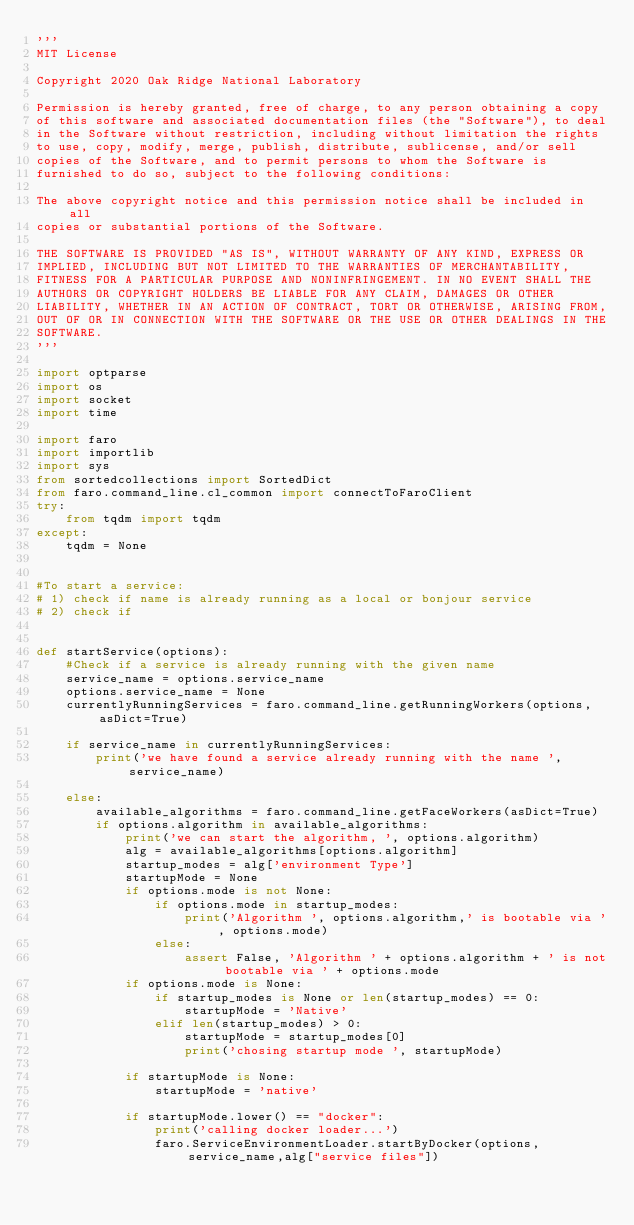<code> <loc_0><loc_0><loc_500><loc_500><_Python_>'''
MIT License

Copyright 2020 Oak Ridge National Laboratory

Permission is hereby granted, free of charge, to any person obtaining a copy
of this software and associated documentation files (the "Software"), to deal
in the Software without restriction, including without limitation the rights
to use, copy, modify, merge, publish, distribute, sublicense, and/or sell
copies of the Software, and to permit persons to whom the Software is
furnished to do so, subject to the following conditions:

The above copyright notice and this permission notice shall be included in all
copies or substantial portions of the Software.

THE SOFTWARE IS PROVIDED "AS IS", WITHOUT WARRANTY OF ANY KIND, EXPRESS OR
IMPLIED, INCLUDING BUT NOT LIMITED TO THE WARRANTIES OF MERCHANTABILITY,
FITNESS FOR A PARTICULAR PURPOSE AND NONINFRINGEMENT. IN NO EVENT SHALL THE
AUTHORS OR COPYRIGHT HOLDERS BE LIABLE FOR ANY CLAIM, DAMAGES OR OTHER
LIABILITY, WHETHER IN AN ACTION OF CONTRACT, TORT OR OTHERWISE, ARISING FROM,
OUT OF OR IN CONNECTION WITH THE SOFTWARE OR THE USE OR OTHER DEALINGS IN THE
SOFTWARE.
'''

import optparse
import os
import socket
import time

import faro
import importlib
import sys
from sortedcollections import SortedDict
from faro.command_line.cl_common import connectToFaroClient
try:
    from tqdm import tqdm
except:
    tqdm = None


#To start a service:
# 1) check if name is already running as a local or bonjour service
# 2) check if


def startService(options):
    #Check if a service is already running with the given name
    service_name = options.service_name
    options.service_name = None
    currentlyRunningServices = faro.command_line.getRunningWorkers(options, asDict=True)

    if service_name in currentlyRunningServices:
        print('we have found a service already running with the name ',service_name)

    else:
        available_algorithms = faro.command_line.getFaceWorkers(asDict=True)
        if options.algorithm in available_algorithms:
            print('we can start the algorithm, ', options.algorithm)
            alg = available_algorithms[options.algorithm]
            startup_modes = alg['environment Type']
            startupMode = None
            if options.mode is not None:
                if options.mode in startup_modes:
                    print('Algorithm ', options.algorithm,' is bootable via ', options.mode)
                else:
                    assert False, 'Algorithm ' + options.algorithm + ' is not bootable via ' + options.mode
            if options.mode is None:
                if startup_modes is None or len(startup_modes) == 0:
                    startupMode = 'Native'
                elif len(startup_modes) > 0:
                    startupMode = startup_modes[0]
                    print('chosing startup mode ', startupMode)

            if startupMode is None:
                startupMode = 'native'

            if startupMode.lower() == "docker":
                print('calling docker loader...')
                faro.ServiceEnvironmentLoader.startByDocker(options,service_name,alg["service files"])



</code> 